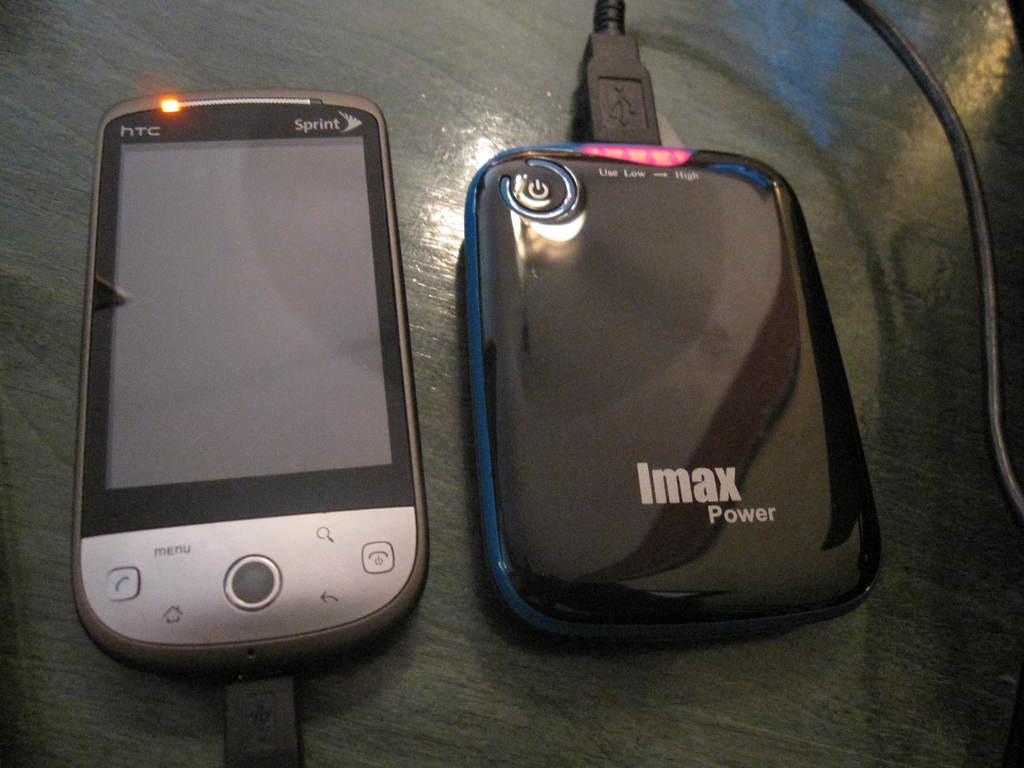<image>
Relay a brief, clear account of the picture shown. An imax power device charging an HTC device. 